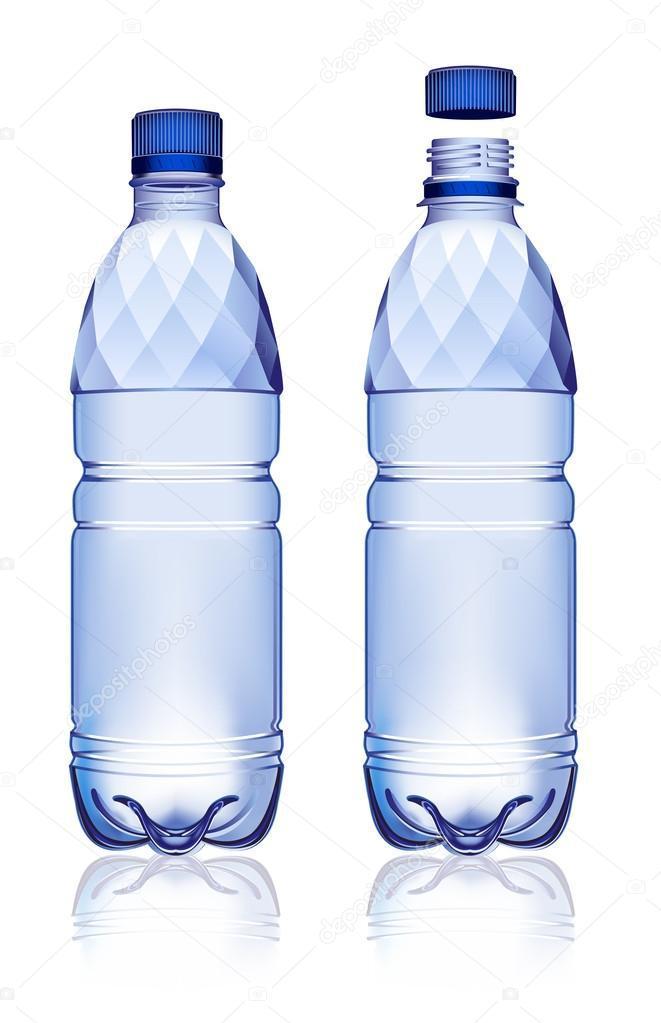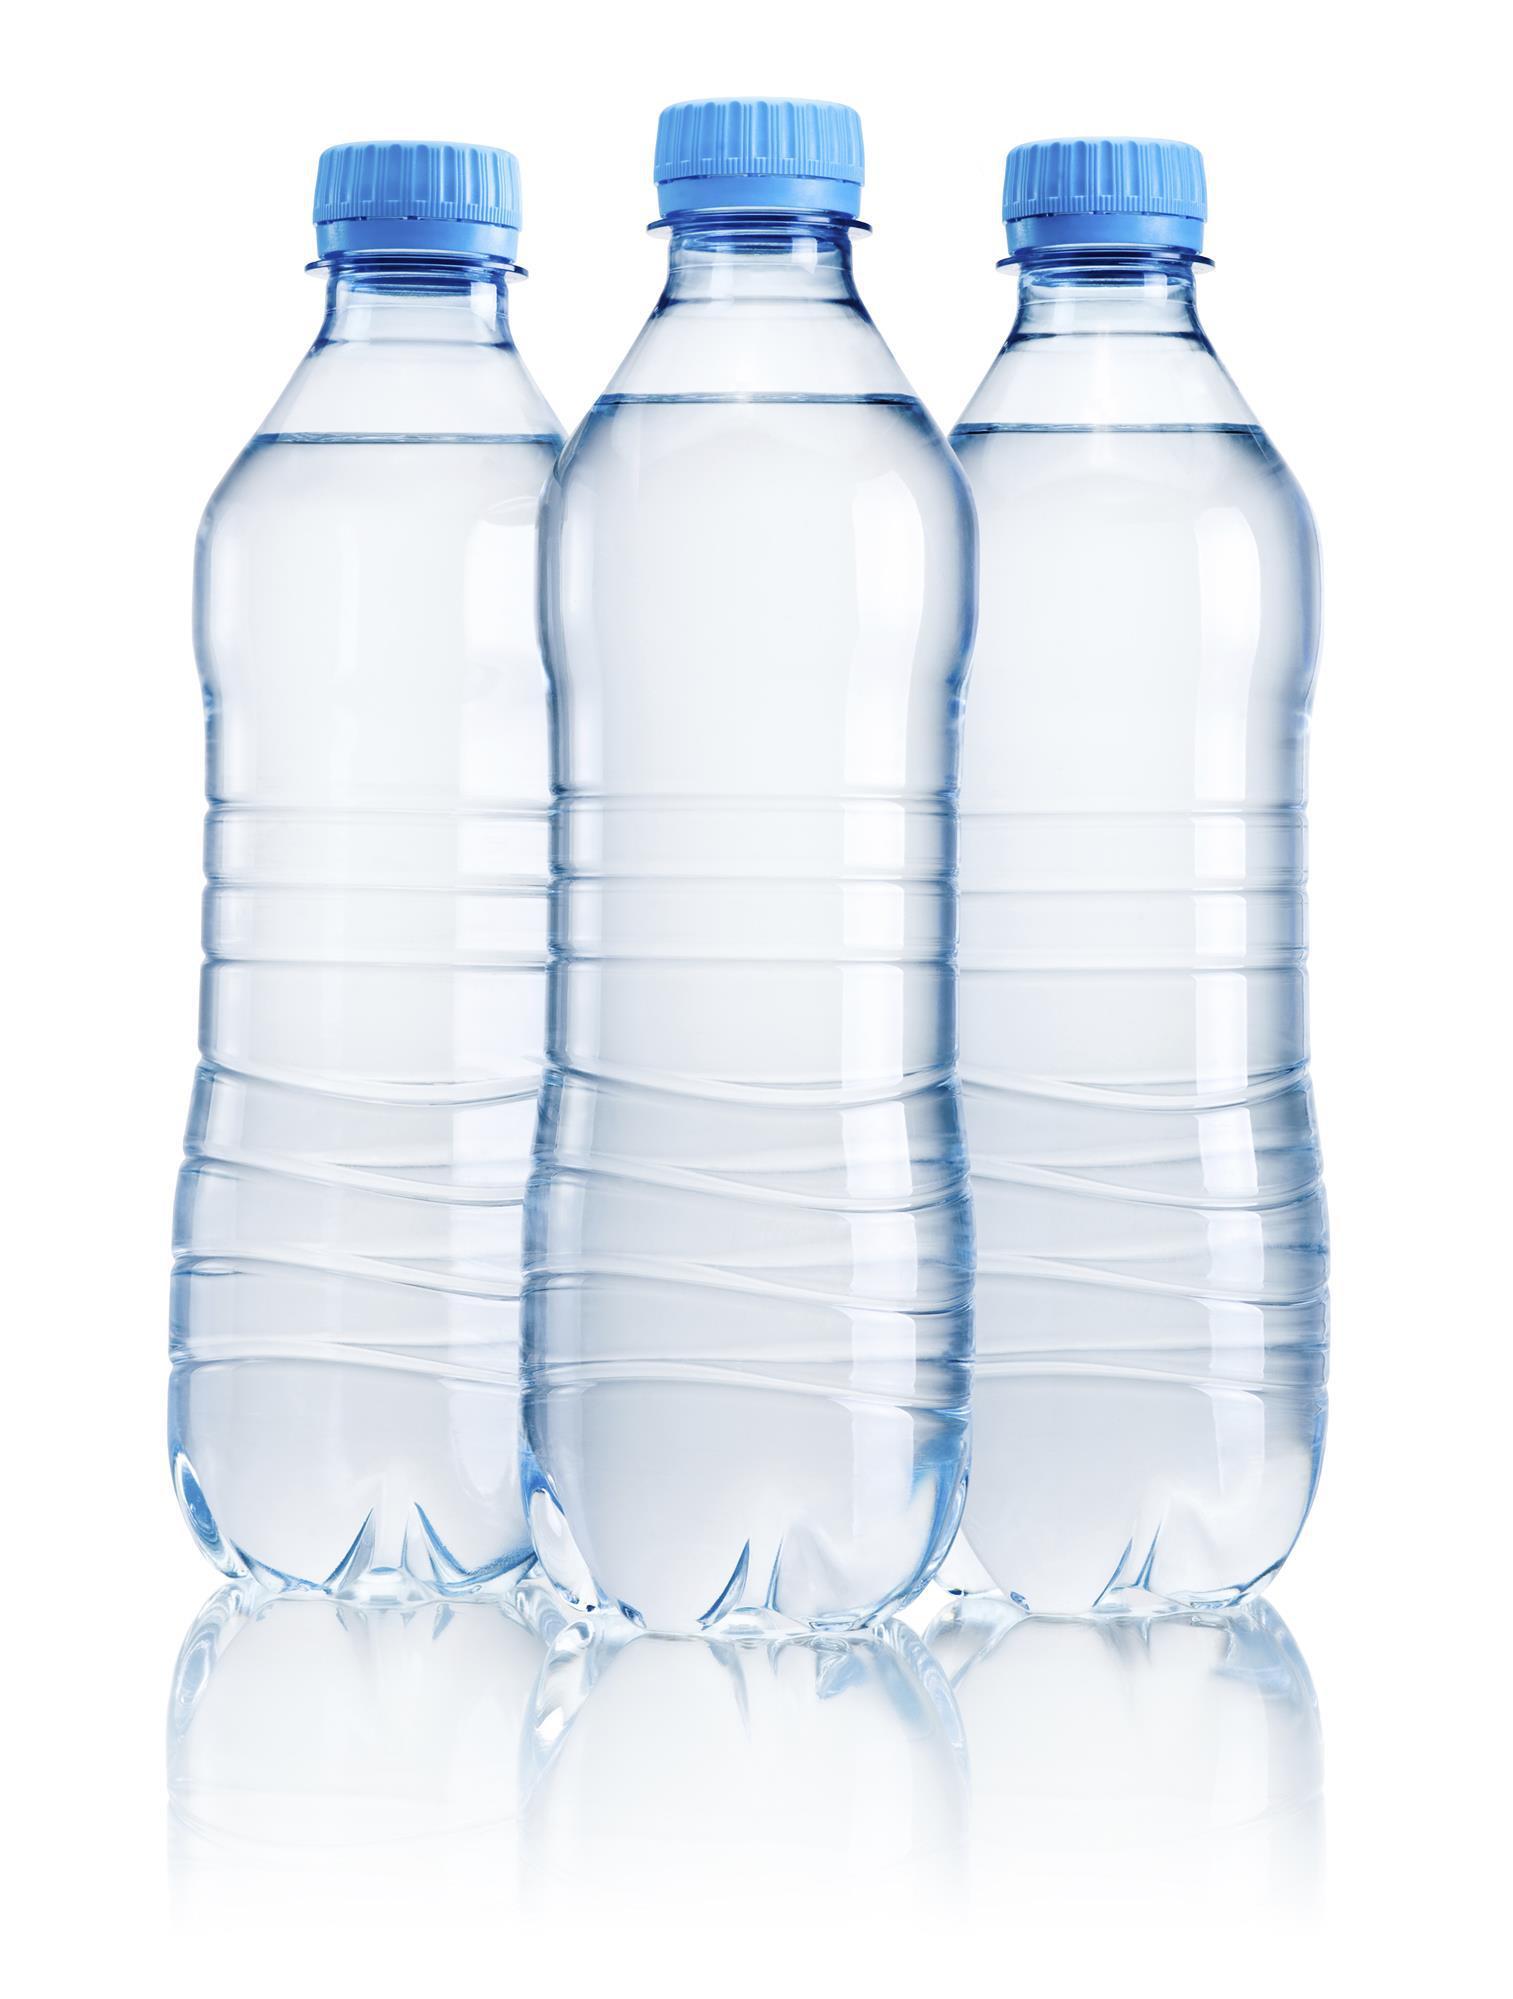The first image is the image on the left, the second image is the image on the right. Assess this claim about the two images: "An image shows at least one filled water bottle with a blue lid and no label.". Correct or not? Answer yes or no. Yes. The first image is the image on the left, the second image is the image on the right. Considering the images on both sides, is "None of the bottles have a label." valid? Answer yes or no. Yes. 